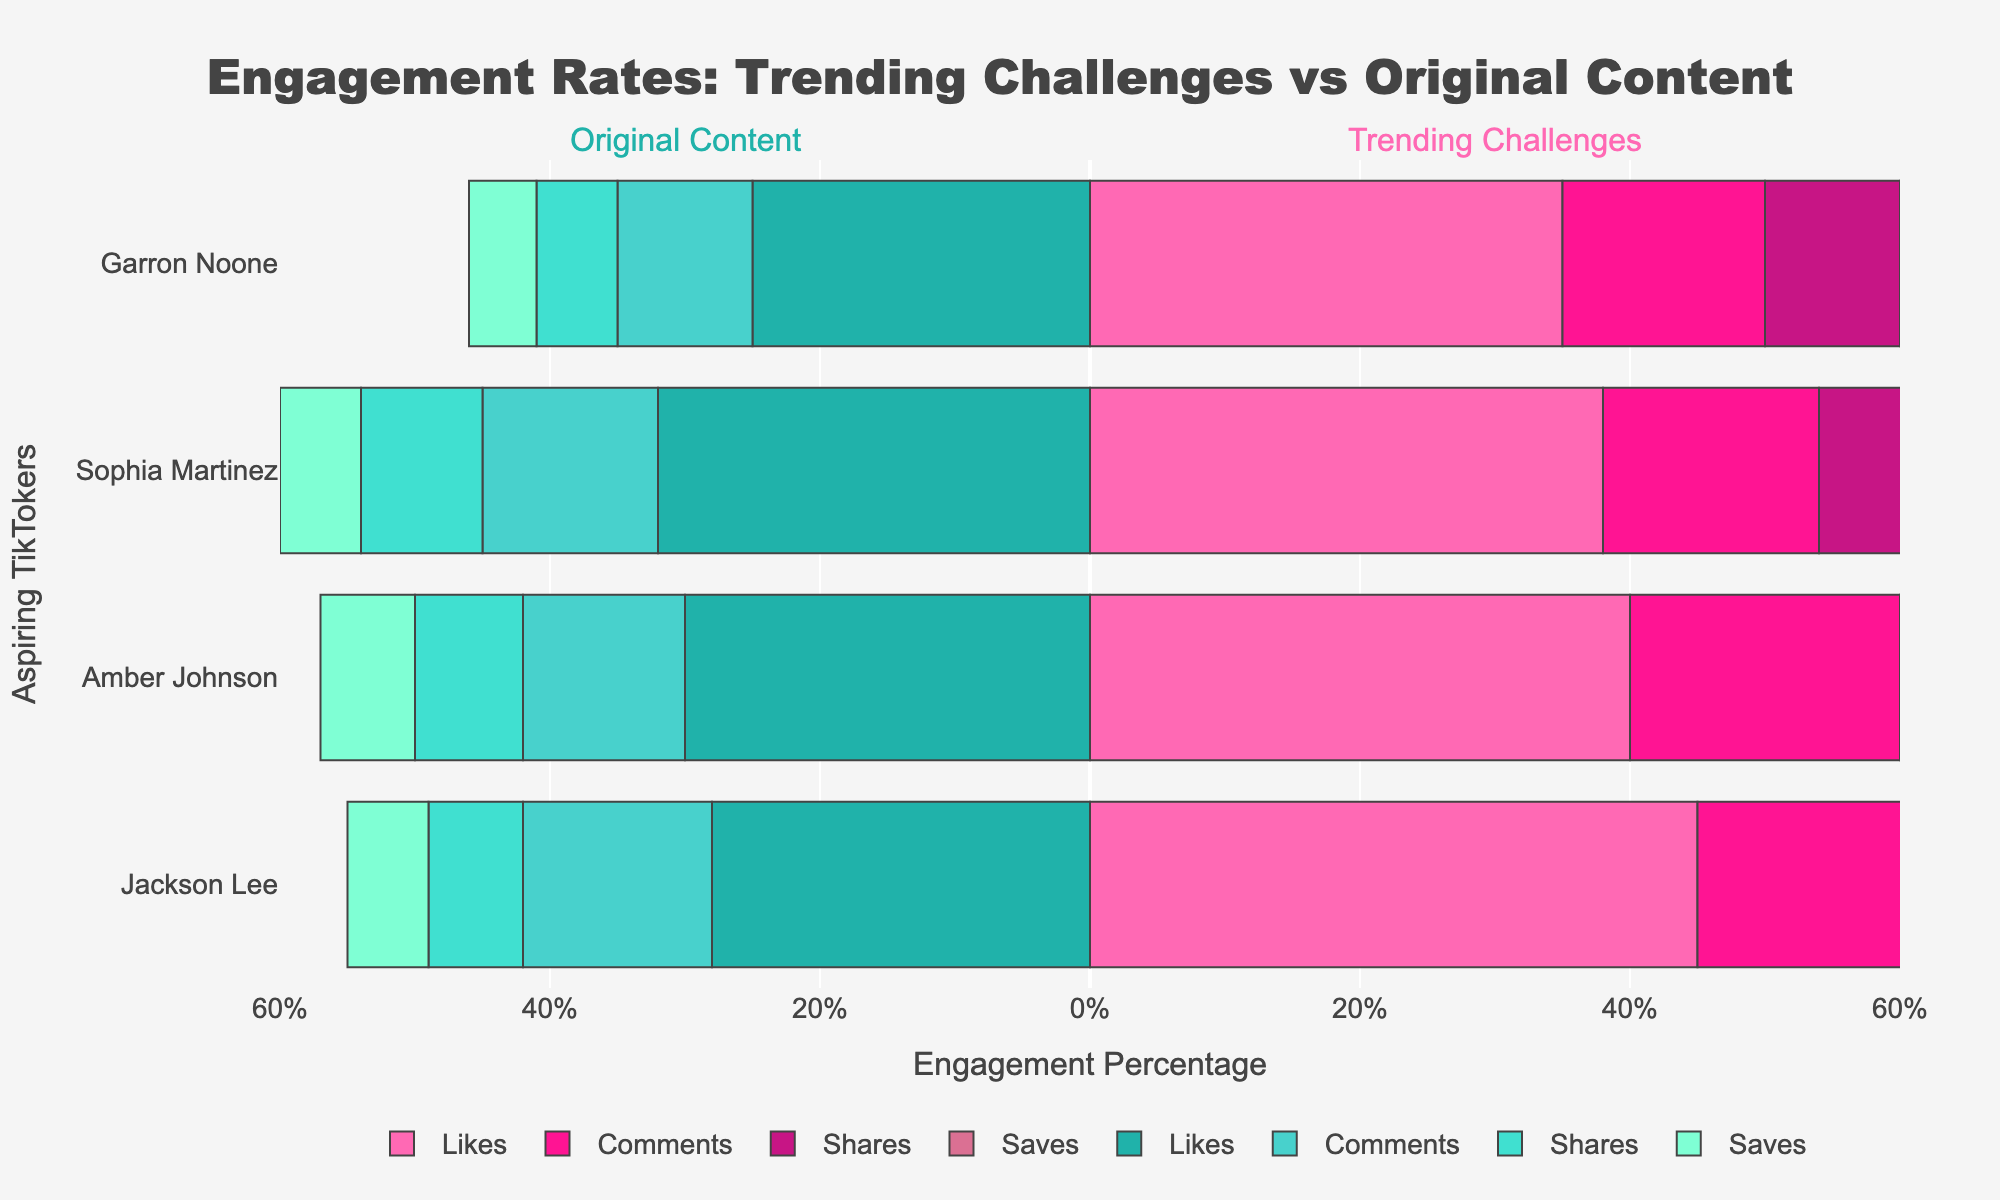Which aspiring TikToker received the most likes for trending challenges? Look at the bar lengths representing 'Likes' for trending challenges and compare the lengths. Jackson Lee has the longest bar.
Answer: Jackson Lee Who has the highest overall engagement percentage for original content? Add the heights of the bars representing likes, comments, shares, and saves for each aspiring TikToker for original content. Sophia Martinez has the highest total.
Answer: Sophia Martinez What is the difference in the number of likes between Garron Noone's trending challenges and original content? Subtract the original content likes for Garron Noone from the trending challenges likes (35 - 25 = 10).
Answer: 10 Which TikToker sees a larger difference in engagement percentage between their trending challenges and original content for shares? Compare the absolute difference in engagement percentage for shares between trending challenges and original content for each TikToker. Jackson Lee has the larger difference (14 for trending challenges vs. 7 for original content = 7).
Answer: Jackson Lee How do Amber Johnson's comments for trending challenges compare to Sophia Martinez's comments for original content? Compare the bar length representing 'Comments' for trending challenges for Amber Johnson to the bar representing 'Comments' for Sophia Martinez's original content. Amber Johnson's bar (20%) is longer than Sophia Martinez's (13%).
Answer: Greater Which engagement type shows the smallest difference between trending challenges and original content across all TikTokers? Identify the engagement type with the smallest differences in bar lengths between trending challenges and original content. 'Saves' seems to have the smallest differences.
Answer: Saves What is the total engagement percentage for all types of engagement combined for Jackson Lee's original content? Sum the engagement percentages for Jackson Lee's original content: Likes (28) + Comments (14) + Shares (7) + Saves (6) = 55.
Answer: 55 Is there any TikToker whose share engagement is higher for original content than for trending challenges? Compare the share engagement percentages for trending challenges and original content for each TikToker. None of the TikTokers have higher shares for original content than for trending challenges.
Answer: No Between Garron Noone and Amber Johnson, who has a higher total engagement for original content? Add the engagement percentages (likes, comments, shares, saves) for original content for both TikTokers and compare. Amber Johnson (30+12+8+7=57) has higher total engagement than Garron Noone (25+10+6+5=46).
Answer: Amber Johnson 